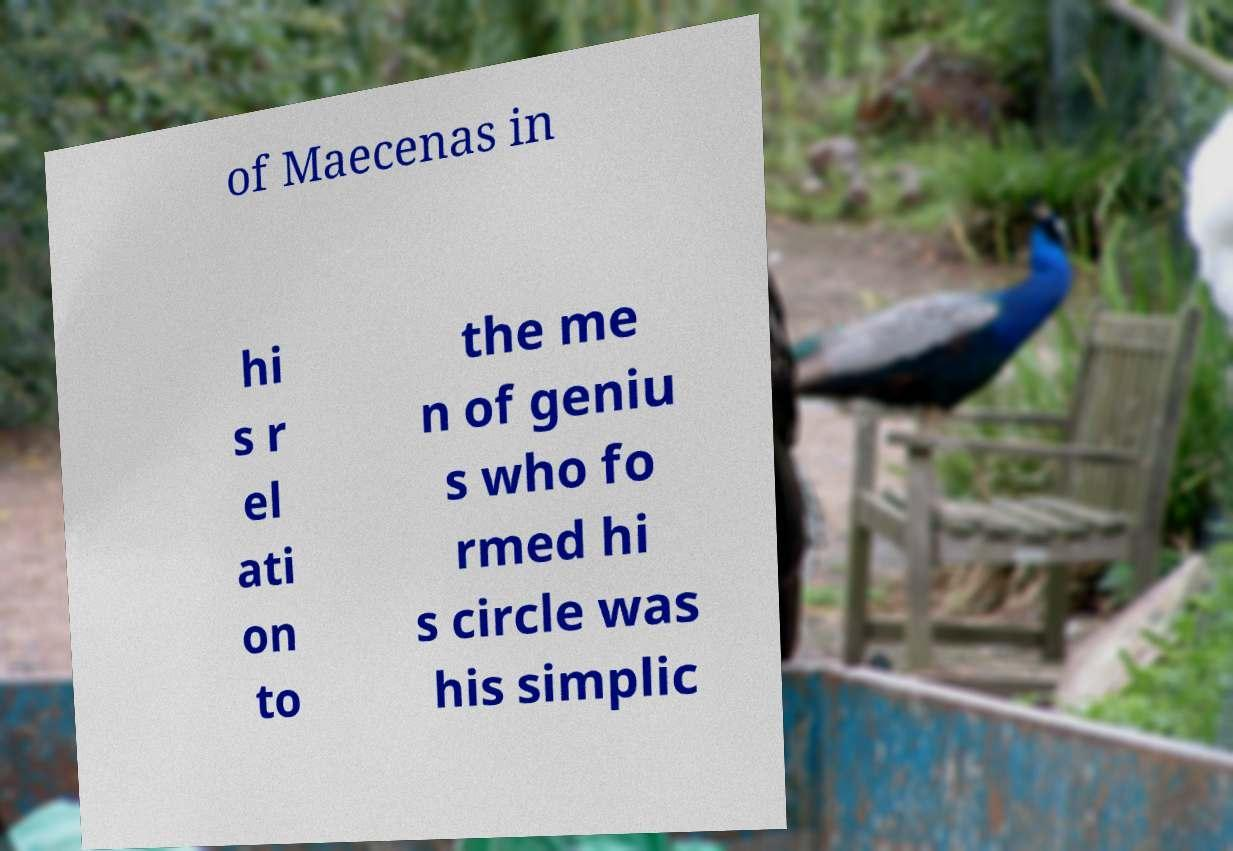There's text embedded in this image that I need extracted. Can you transcribe it verbatim? of Maecenas in hi s r el ati on to the me n of geniu s who fo rmed hi s circle was his simplic 